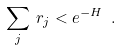Convert formula to latex. <formula><loc_0><loc_0><loc_500><loc_500>\sum _ { j } \, r _ { j } < e ^ { - H } \ .</formula> 